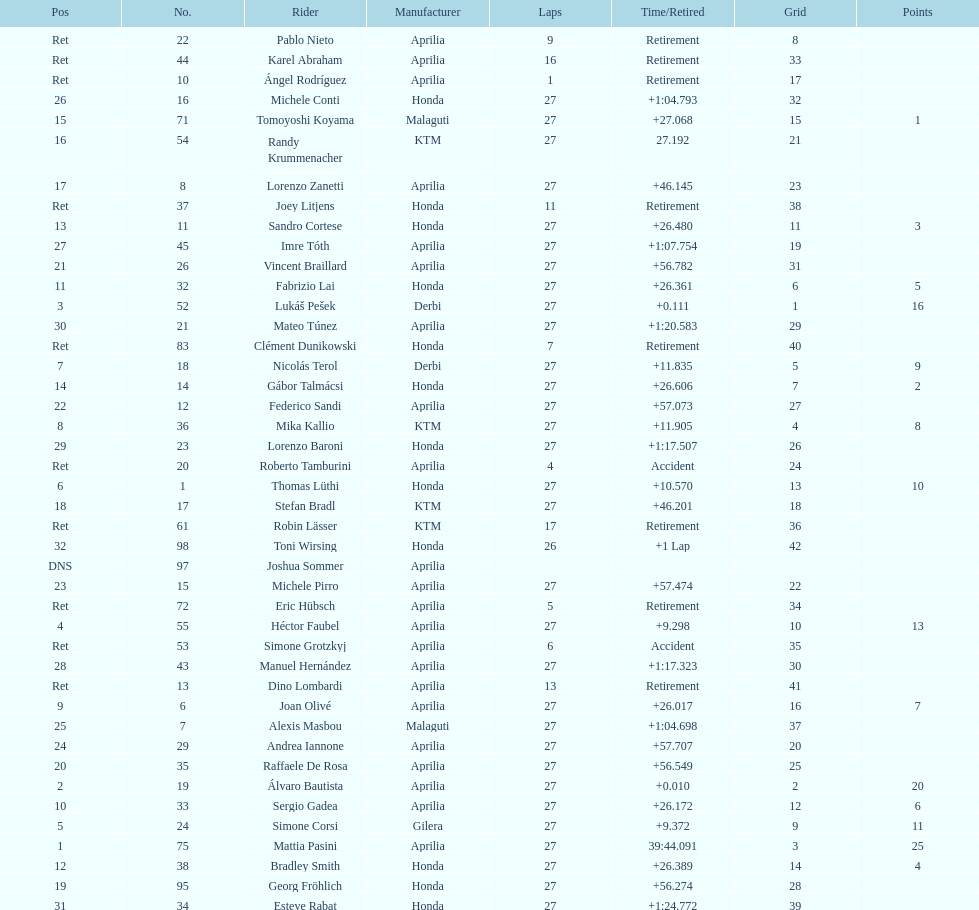How many german racers finished the race? 4. 